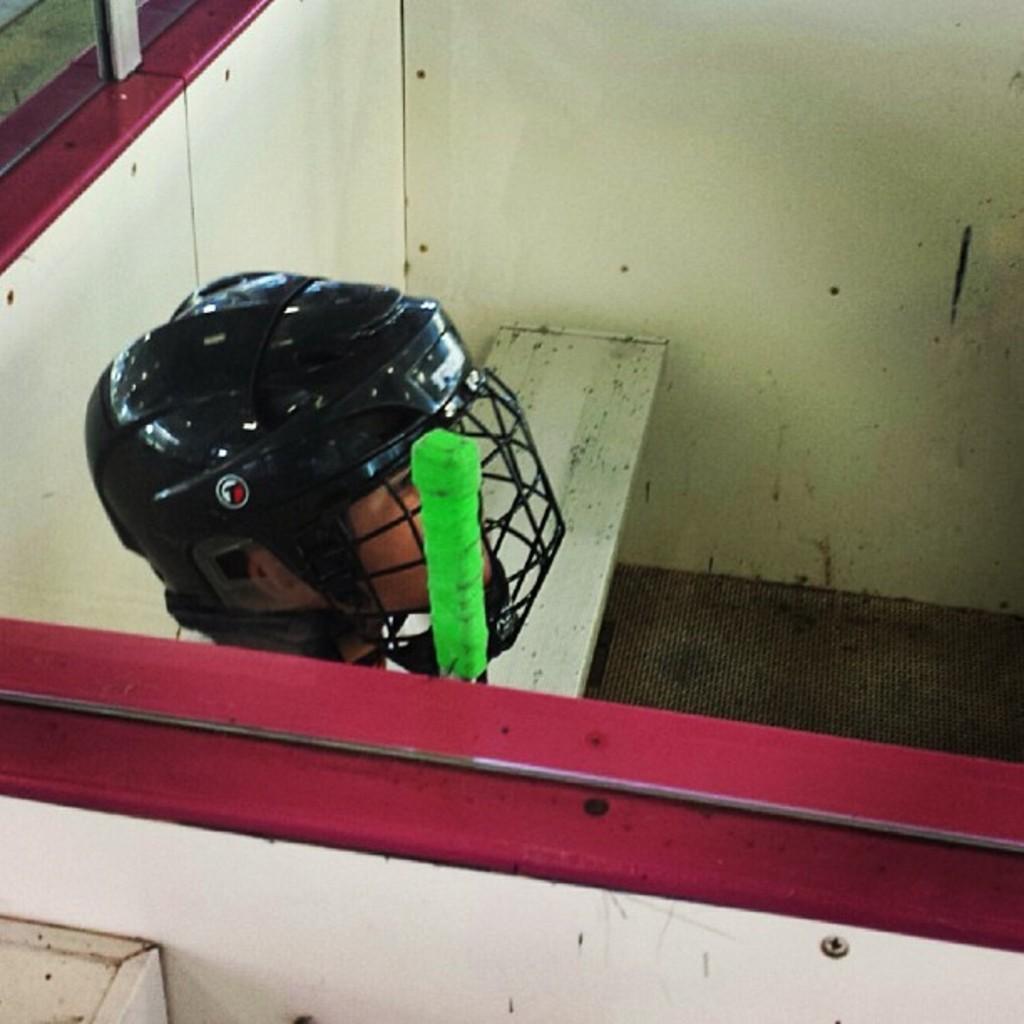Please provide a concise description of this image. In this image we can see a person wearing a helmet, there are windows, bench, wall and a green colored object. 